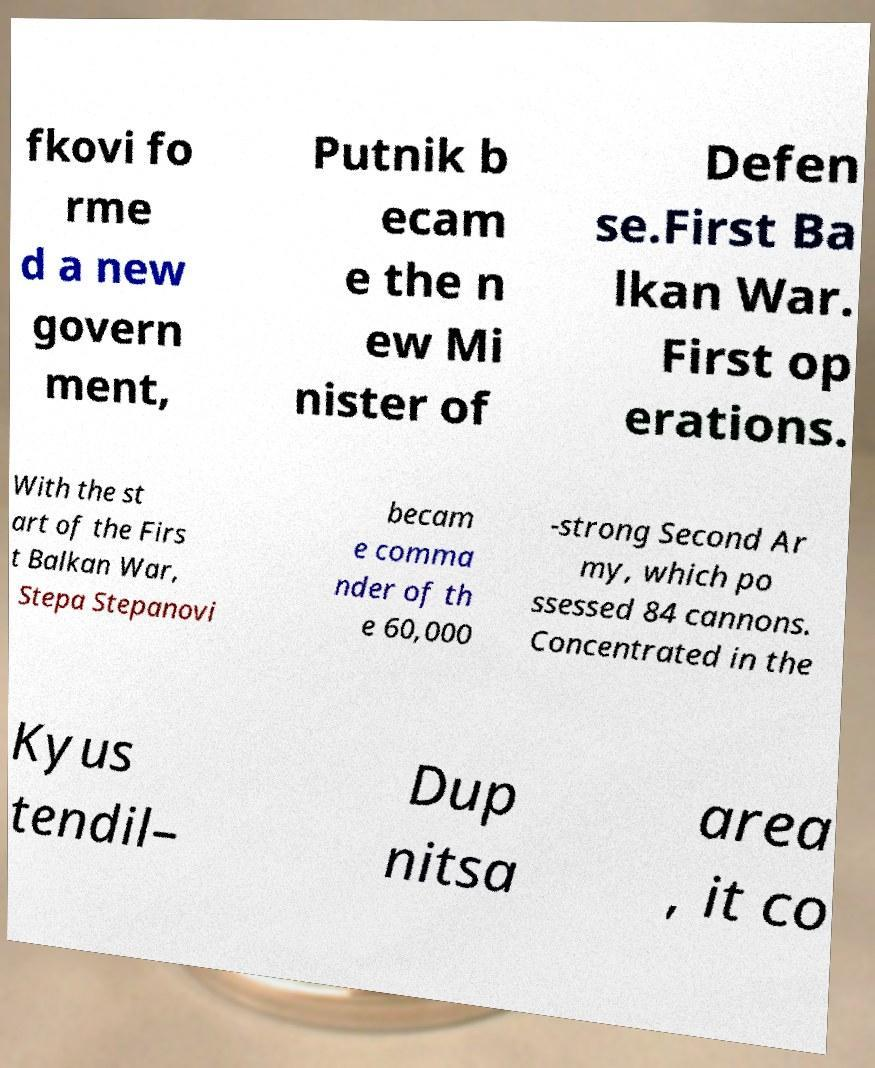Please identify and transcribe the text found in this image. fkovi fo rme d a new govern ment, Putnik b ecam e the n ew Mi nister of Defen se.First Ba lkan War. First op erations. With the st art of the Firs t Balkan War, Stepa Stepanovi becam e comma nder of th e 60,000 -strong Second Ar my, which po ssessed 84 cannons. Concentrated in the Kyus tendil– Dup nitsa area , it co 